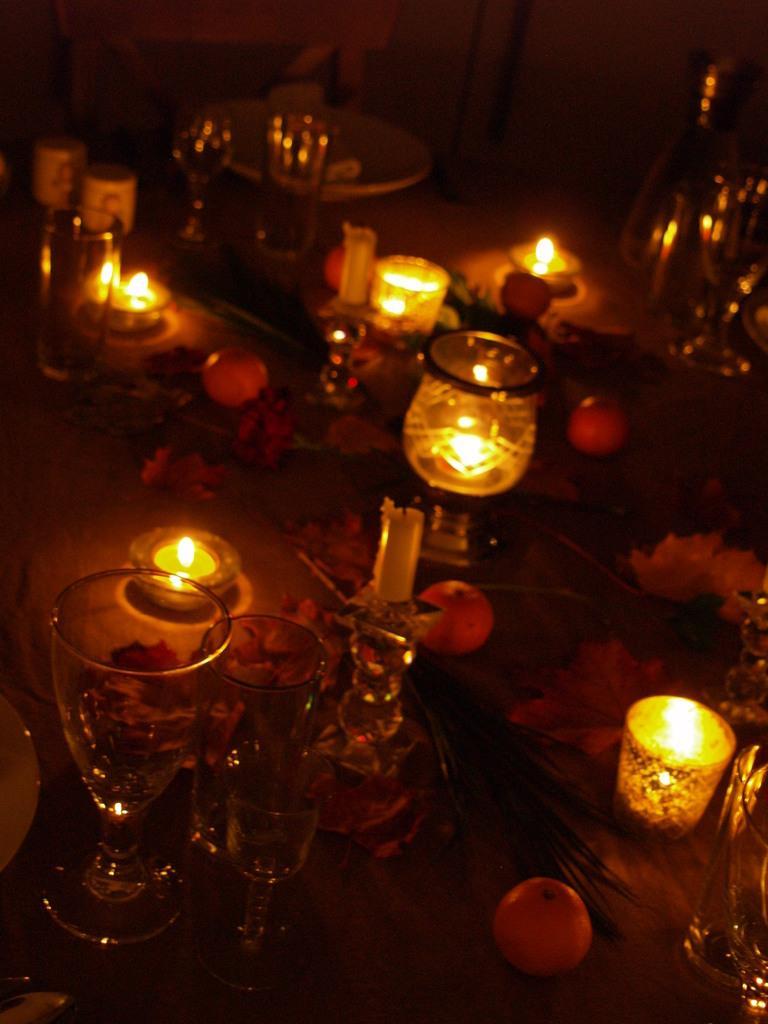Describe this image in one or two sentences. On a table there are some glasses and plates and the table is decorated with beautiful candles and fruits and flowers. 